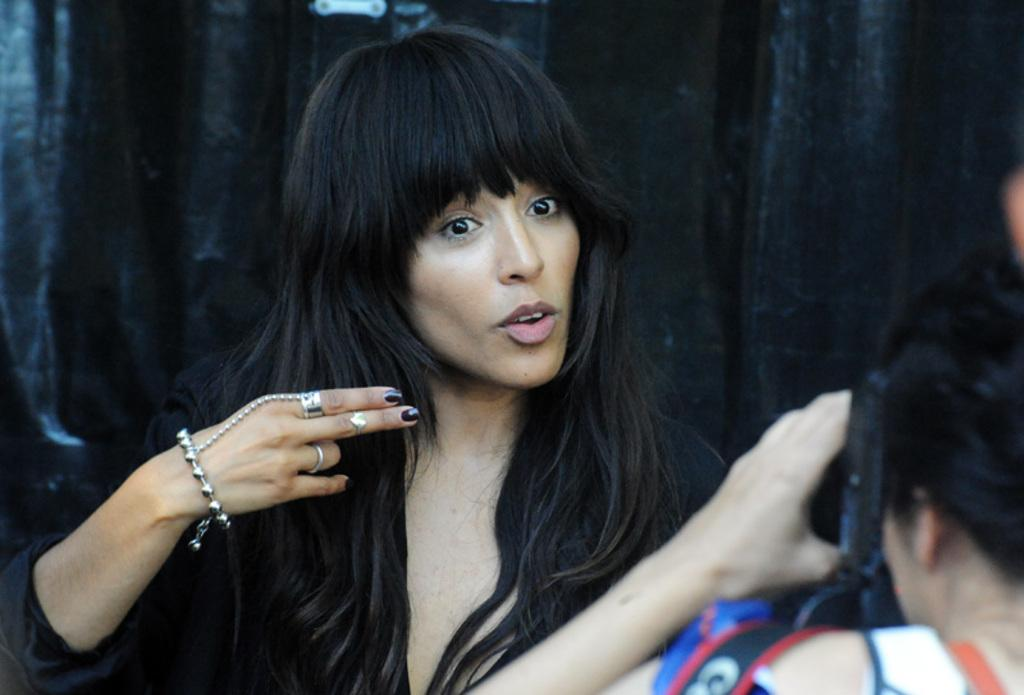How many people are in the image? There are two people in the image. What is one person doing in the image? One person is holding a camera. What can be observed about the background of the image? The background appears to be black in color. What type of flesh can be seen on the horse's brain in the image? There is no horse or brain present in the image, and therefore no flesh can be observed. 